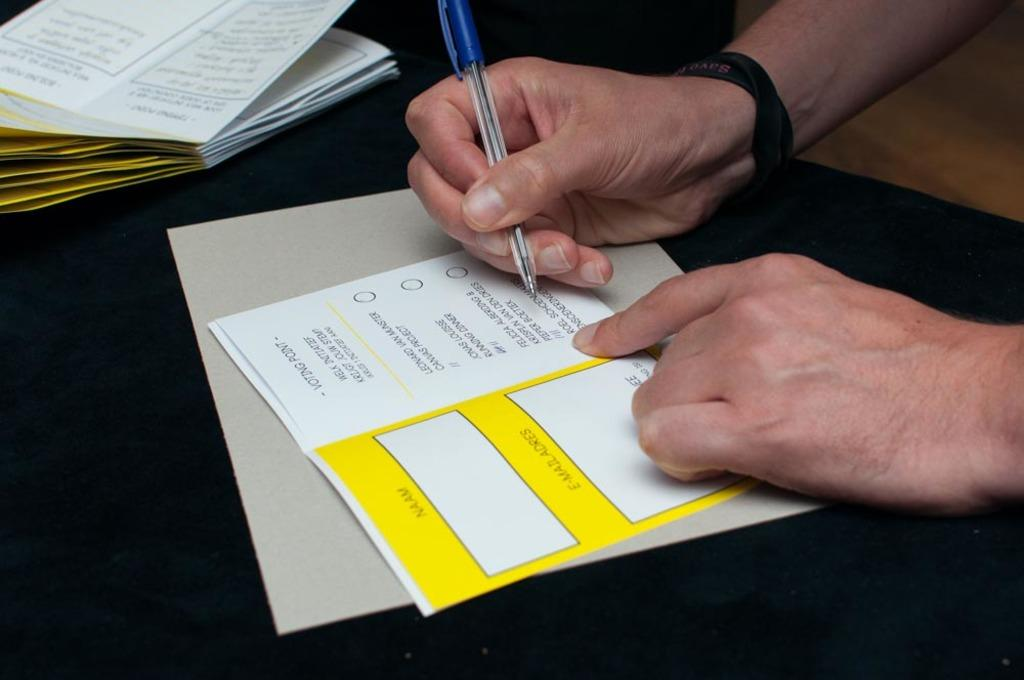<image>
Write a terse but informative summary of the picture. A hand filling out a voting ballot with the words Voting point printed on top 